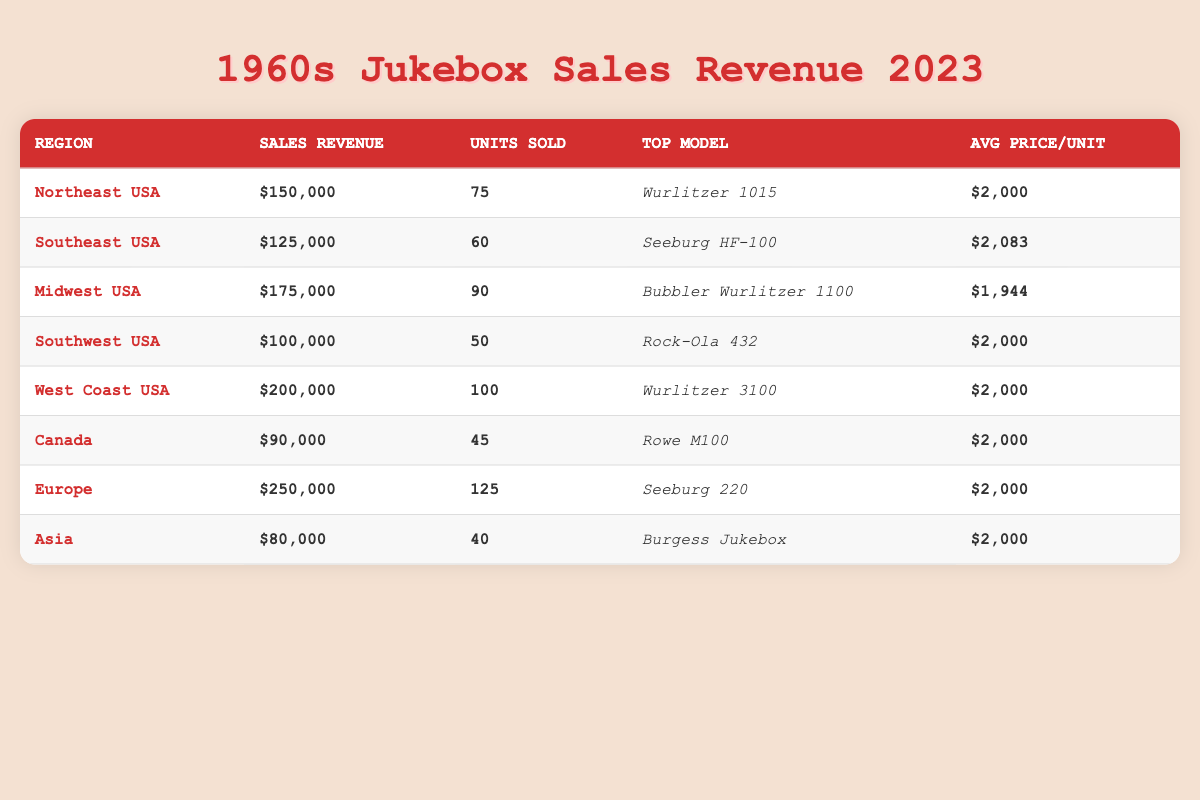What is the total sales revenue from all regions? To find the total sales revenue, we add up the sales revenue for each region: $150,000 + $125,000 + $175,000 + $100,000 + $200,000 + $90,000 + $250,000 + $80,000 = $1,020,000.
Answer: $1,020,000 Which region sold the highest number of jukebox units? The number of units sold by region is as follows: Northeast USA (75), Southeast USA (60), Midwest USA (90), Southwest USA (50), West Coast USA (100), Canada (45), Europe (125), and Asia (40). The highest is 125 units sold in Europe.
Answer: Europe What is the average price per unit sold across all regions? The average price per unit is calculated by summing the average prices and dividing by the number of regions. Since most regions have the same price of $2,000, with one at $2,083, the calculation is ($2,000*7 + $2,083*1)/8 = $2,008.25.
Answer: $2,008.25 Which model had the lowest sales revenue? The sales revenues by region are as follows: Northeast USA ($150,000), Southeast USA ($125,000), Midwest USA ($175,000), Southwest USA ($100,000), West Coast USA ($200,000), Canada ($90,000), Europe ($250,000), and Asia ($80,000). The lowest is $80,000 from Asia.
Answer: Asia Is the Wurlitzer 3100 the top model in more than one region? The top models are as follows: Northeast USA (Wurlitzer 1015), Southeast USA (Seeburg HF-100), Midwest USA (Bubbler Wurlitzer 1100), Southwest USA (Rock-Ola 432), West Coast USA (Wurlitzer 3100), Canada (Rowe M100), Europe (Seeburg 220), and Asia (Burgess Jukebox). The Wurlitzer 3100 only appears once.
Answer: No What is the difference in sales revenue between the West Coast USA and Southwest USA? The sales revenue for the West Coast USA is $200,000 and for Southwest USA is $100,000. The difference is calculated as $200,000 - $100,000 = $100,000.
Answer: $100,000 Which region generated the most sales revenue and how much did it earn? The sales revenues are $150,000, $125,000, $175,000, $100,000, $200,000, $90,000, $250,000, and $80,000. The highest is $250,000 from Europe.
Answer: Europe, $250,000 How many more units were sold in the Midwest USA compared to Canada? The Midwest USA sold 90 units while Canada sold 45 units. The difference is calculated as 90 - 45 = 45 more units sold in the Midwest USA.
Answer: 45 What is the total number of units sold across all regions? We sum the units sold: 75 + 60 + 90 + 50 + 100 + 45 + 125 + 40 = 575 units in total.
Answer: 575 Is the average price per unit in Southeast USA higher than that in the Midwest USA? The average price per unit in Southeast USA is $2,083, while in Midwest USA it is $1,944. Since $2,083 > $1,944, it confirms that the Southeast USA has a higher average price.
Answer: Yes 